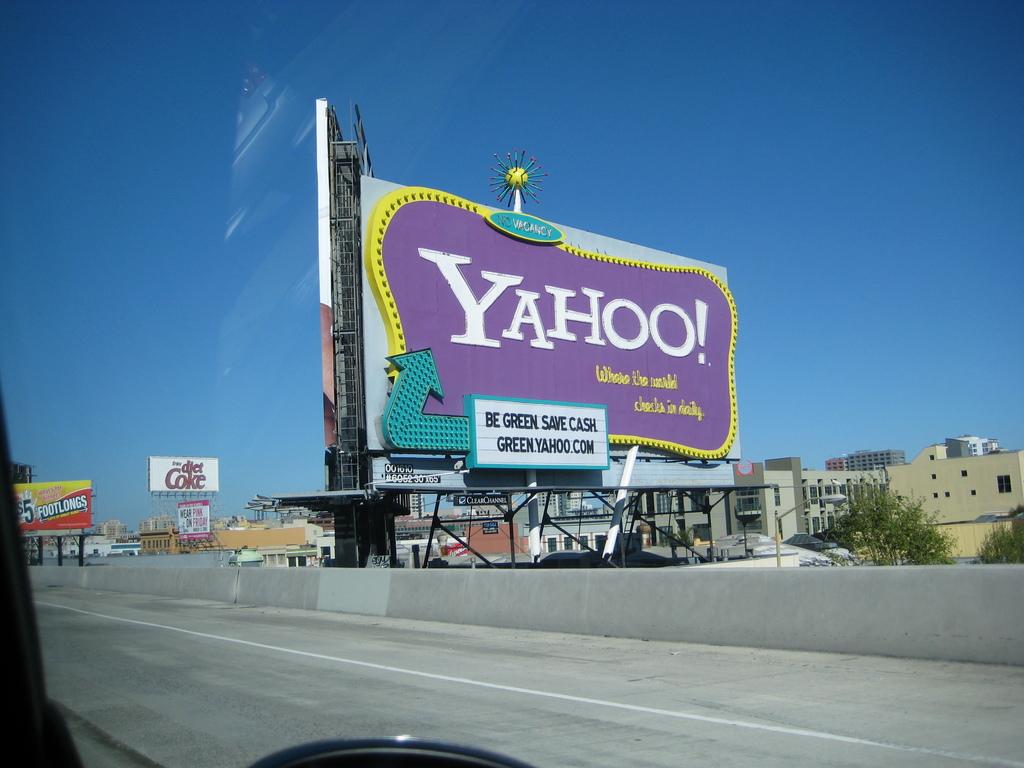What company is the billboard advertising?
Give a very brief answer. Yahoo. 